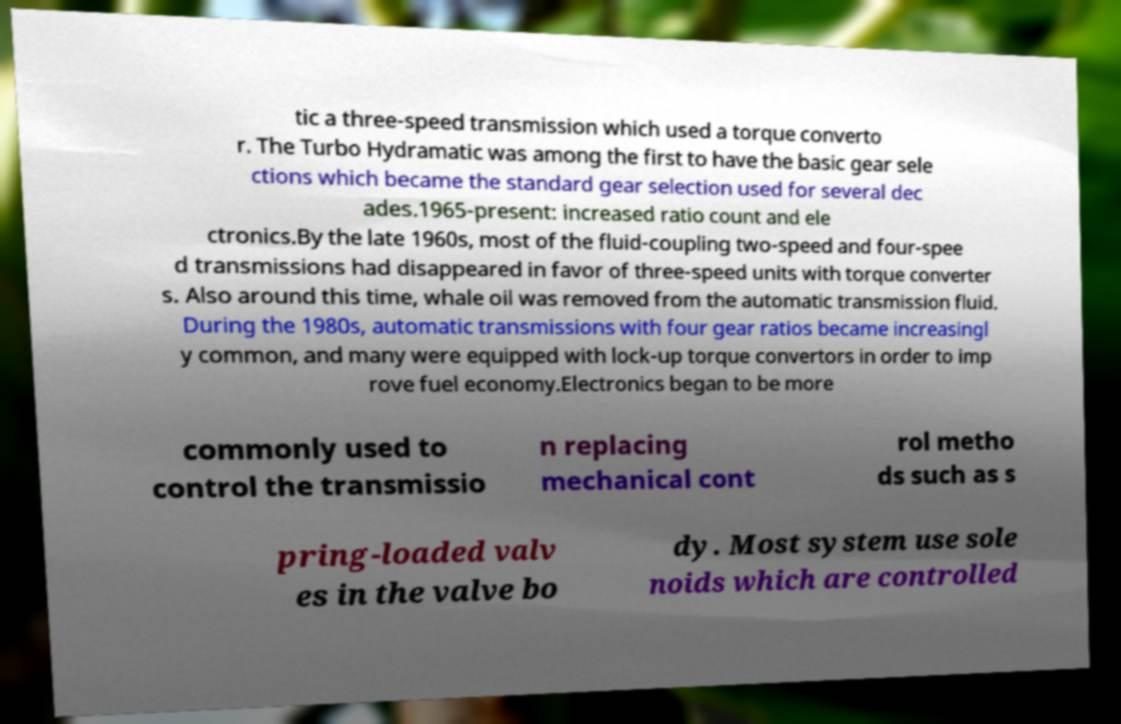I need the written content from this picture converted into text. Can you do that? tic a three-speed transmission which used a torque converto r. The Turbo Hydramatic was among the first to have the basic gear sele ctions which became the standard gear selection used for several dec ades.1965-present: increased ratio count and ele ctronics.By the late 1960s, most of the fluid-coupling two-speed and four-spee d transmissions had disappeared in favor of three-speed units with torque converter s. Also around this time, whale oil was removed from the automatic transmission fluid. During the 1980s, automatic transmissions with four gear ratios became increasingl y common, and many were equipped with lock-up torque convertors in order to imp rove fuel economy.Electronics began to be more commonly used to control the transmissio n replacing mechanical cont rol metho ds such as s pring-loaded valv es in the valve bo dy. Most system use sole noids which are controlled 